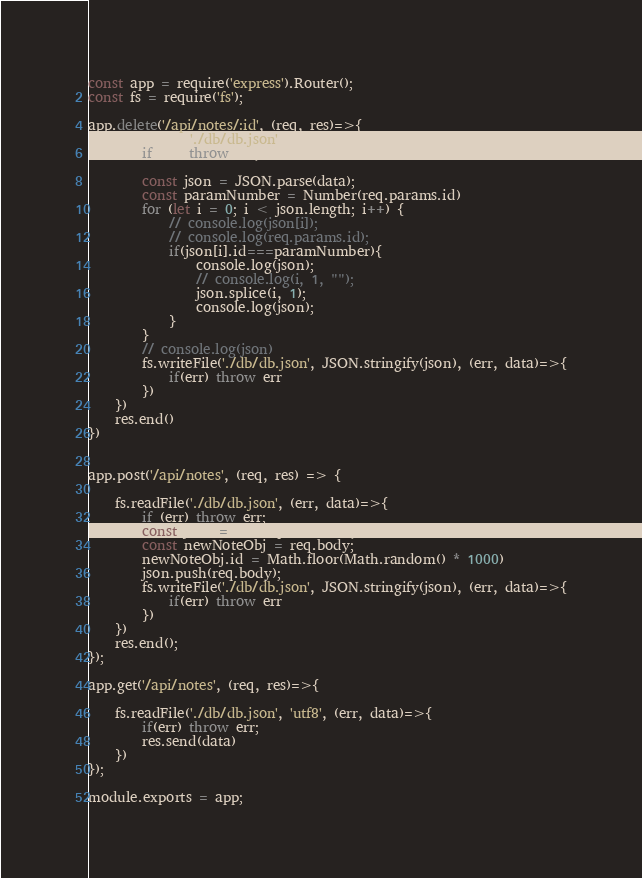Convert code to text. <code><loc_0><loc_0><loc_500><loc_500><_JavaScript_>const app = require('express').Router();
const fs = require('fs');

app.delete('/api/notes/:id', (req, res)=>{
    fs.readFile('./db/db.json', (err, data)=>{
        if(err) throw err;
      
        const json = JSON.parse(data);
        const paramNumber = Number(req.params.id)
        for (let i = 0; i < json.length; i++) {
            // console.log(json[i]);
            // console.log(req.params.id);
            if(json[i].id===paramNumber){
                console.log(json);
                // console.log(i, 1, "");
                json.splice(i, 1);
                console.log(json);
            }
        }
        // console.log(json)
        fs.writeFile('./db/db.json', JSON.stringify(json), (err, data)=>{
            if(err) throw err
        })
    })
    res.end()
})


app.post('/api/notes', (req, res) => {

    fs.readFile('./db/db.json', (err, data)=>{
        if (err) throw err;
        const json = JSON.parse(data);
        const newNoteObj = req.body;
        newNoteObj.id = Math.floor(Math.random() * 1000)
        json.push(req.body);
        fs.writeFile('./db/db.json', JSON.stringify(json), (err, data)=>{
            if(err) throw err
        })
    })
    res.end();
});

app.get('/api/notes', (req, res)=>{
    
    fs.readFile('./db/db.json', 'utf8', (err, data)=>{
        if(err) throw err;
        res.send(data)
    })
});

module.exports = app;</code> 